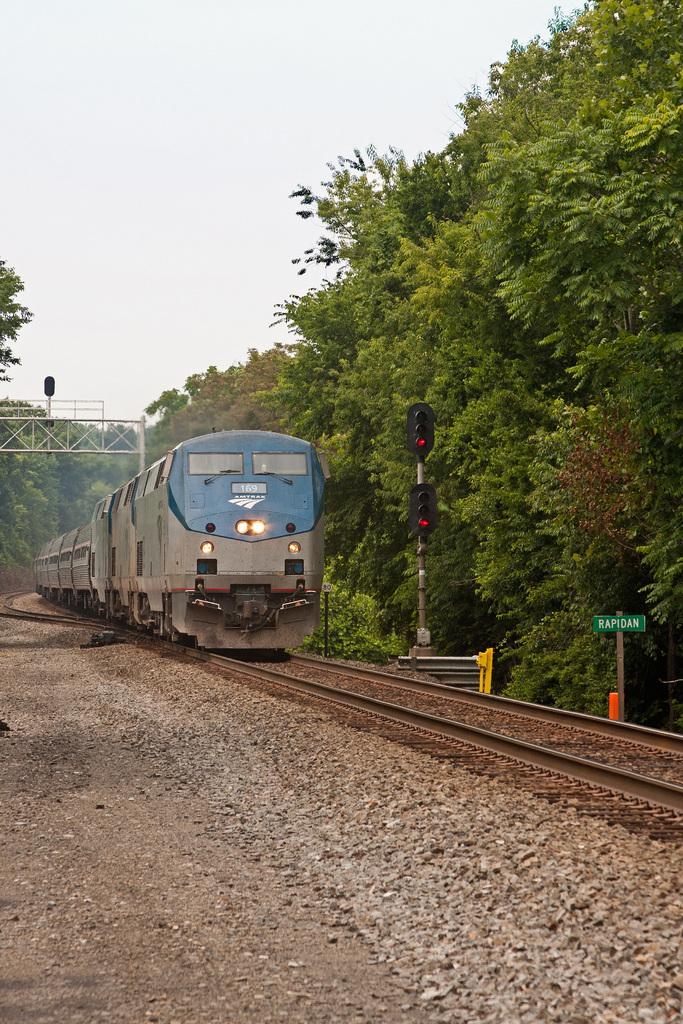What is the main subject of the image? The main subject of the image is a train on the track. What other objects or features can be seen in the image? There are stones, a signboard, a traffic signal, a metal frame, a group of trees, and the sky visible in the image. Can you describe the sky in the image? The sky looks cloudy in the image. How much money is being exchanged between the trees in the image? There is no money exchange happening between the trees in the image; they are simply a group of trees. 